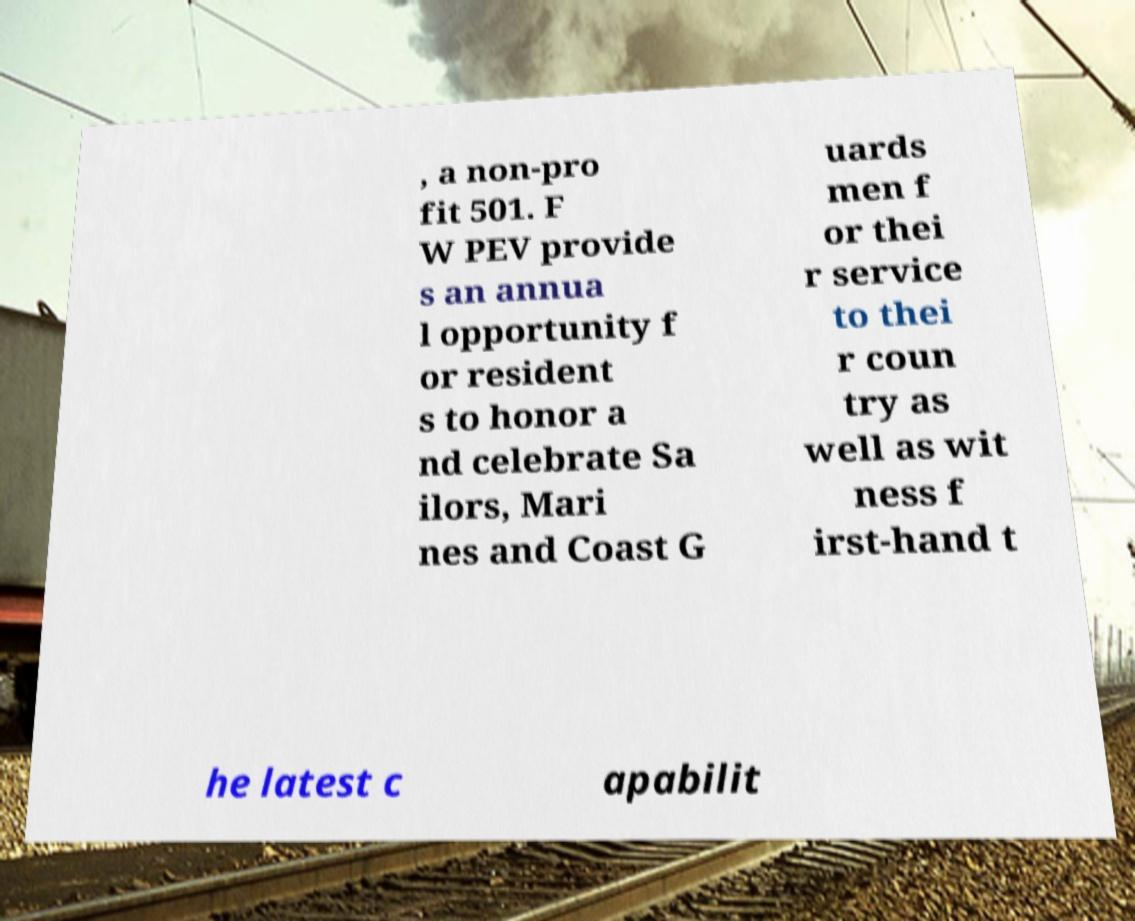Please identify and transcribe the text found in this image. , a non-pro fit 501. F W PEV provide s an annua l opportunity f or resident s to honor a nd celebrate Sa ilors, Mari nes and Coast G uards men f or thei r service to thei r coun try as well as wit ness f irst-hand t he latest c apabilit 